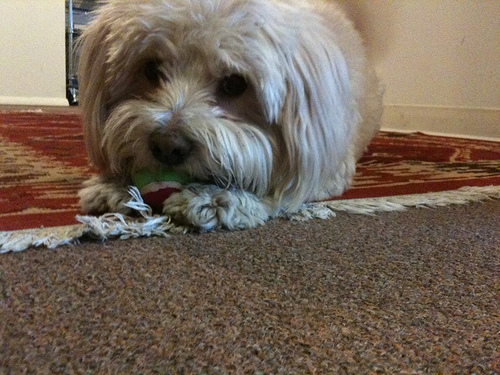<image>
Is the dog behind the wall? No. The dog is not behind the wall. From this viewpoint, the dog appears to be positioned elsewhere in the scene. 